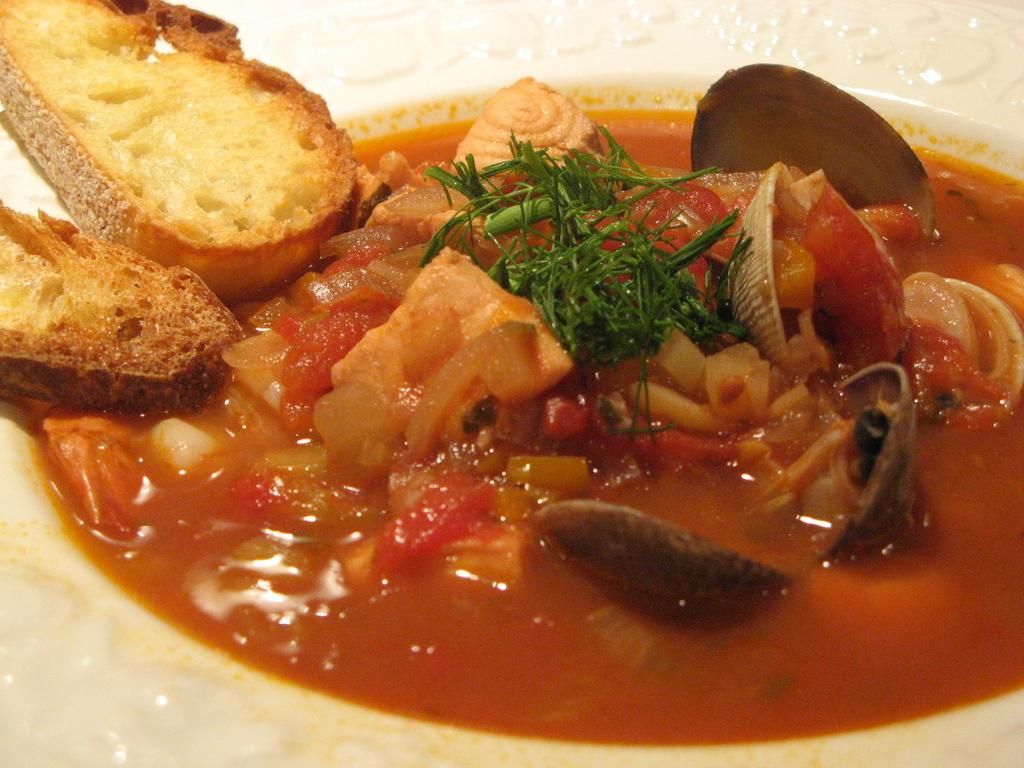What is the main object in the center of the image? There is a plate in the center of the image. What is on the plate? The plate contains breads. Are there any other food items on the plate? Yes, there are food items on the plate. Can you see a bee buzzing around the breads on the plate? No, there is no bee present in the image. What part of the plate is being rubbed by a cloth? There is no cloth or rubbing action depicted in the image. 